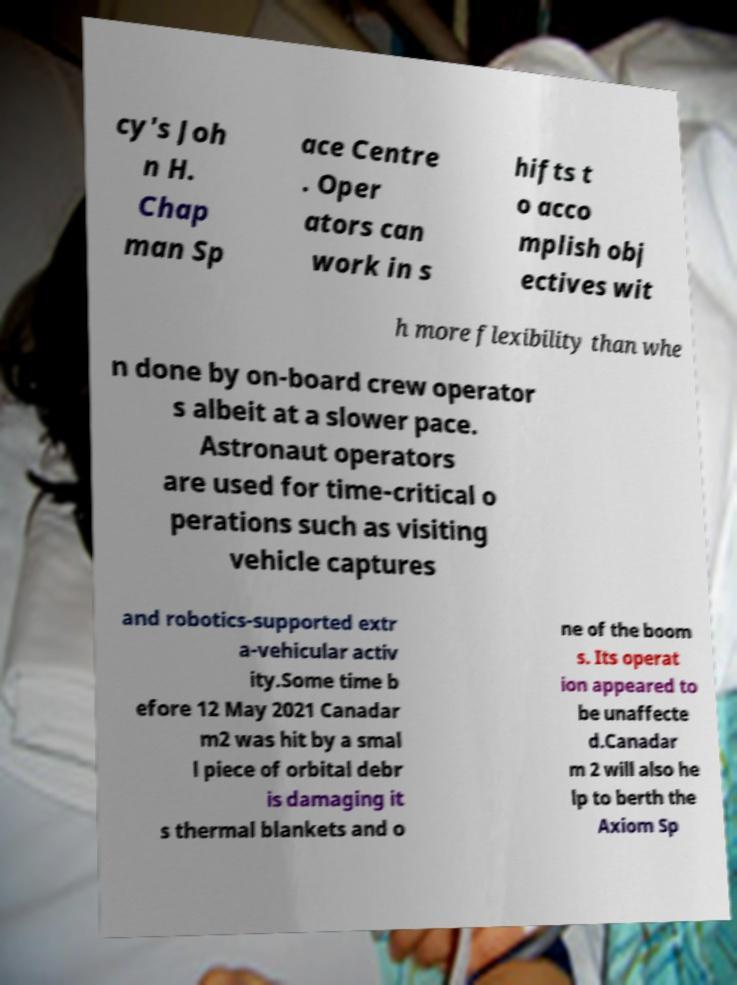Could you extract and type out the text from this image? cy's Joh n H. Chap man Sp ace Centre . Oper ators can work in s hifts t o acco mplish obj ectives wit h more flexibility than whe n done by on-board crew operator s albeit at a slower pace. Astronaut operators are used for time-critical o perations such as visiting vehicle captures and robotics-supported extr a-vehicular activ ity.Some time b efore 12 May 2021 Canadar m2 was hit by a smal l piece of orbital debr is damaging it s thermal blankets and o ne of the boom s. Its operat ion appeared to be unaffecte d.Canadar m 2 will also he lp to berth the Axiom Sp 